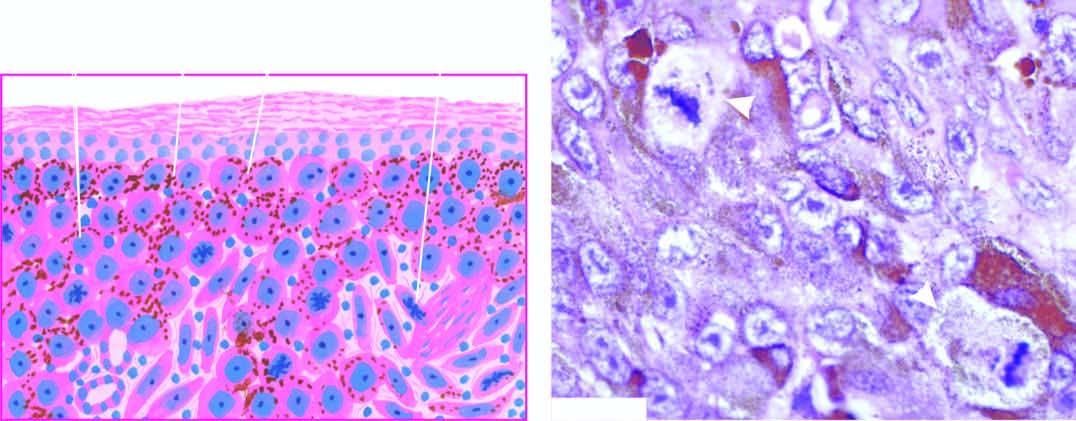what shows a prominent atypical mitotic figure?
Answer the question using a single word or phrase. Photomicrograph 